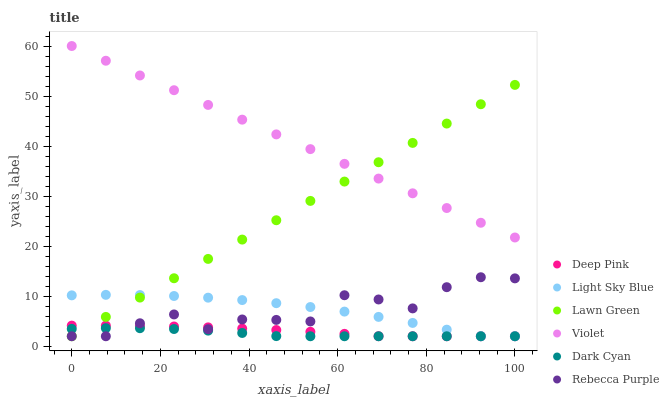Does Dark Cyan have the minimum area under the curve?
Answer yes or no. Yes. Does Violet have the maximum area under the curve?
Answer yes or no. Yes. Does Deep Pink have the minimum area under the curve?
Answer yes or no. No. Does Deep Pink have the maximum area under the curve?
Answer yes or no. No. Is Lawn Green the smoothest?
Answer yes or no. Yes. Is Rebecca Purple the roughest?
Answer yes or no. Yes. Is Deep Pink the smoothest?
Answer yes or no. No. Is Deep Pink the roughest?
Answer yes or no. No. Does Lawn Green have the lowest value?
Answer yes or no. Yes. Does Violet have the lowest value?
Answer yes or no. No. Does Violet have the highest value?
Answer yes or no. Yes. Does Deep Pink have the highest value?
Answer yes or no. No. Is Deep Pink less than Violet?
Answer yes or no. Yes. Is Violet greater than Deep Pink?
Answer yes or no. Yes. Does Rebecca Purple intersect Deep Pink?
Answer yes or no. Yes. Is Rebecca Purple less than Deep Pink?
Answer yes or no. No. Is Rebecca Purple greater than Deep Pink?
Answer yes or no. No. Does Deep Pink intersect Violet?
Answer yes or no. No. 